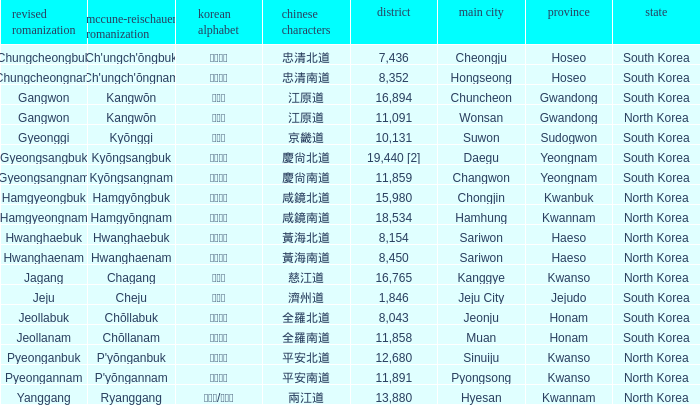Which country has a city with a Hanja of 平安北道? North Korea. 